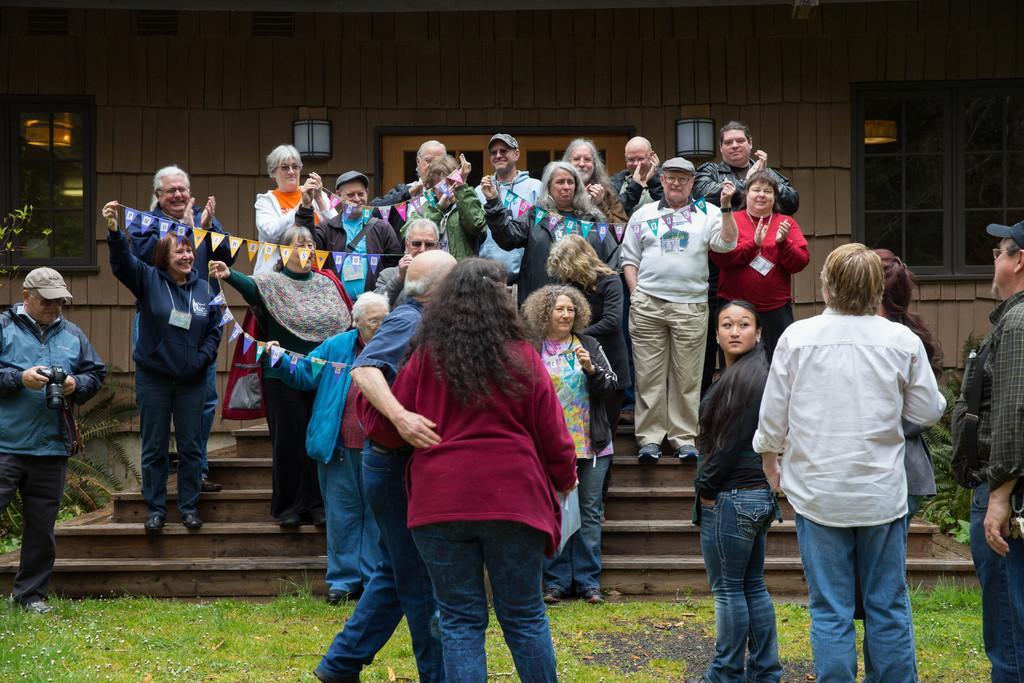In one or two sentences, can you explain what this image depicts? In the image there are a group of people and some of them are holding some flags with their hands, on the left side there is a man he is holding a camera, in the background there are windows and in between the windows there is a door, around the door there is a wall and there are two lights fixed to the wall. 